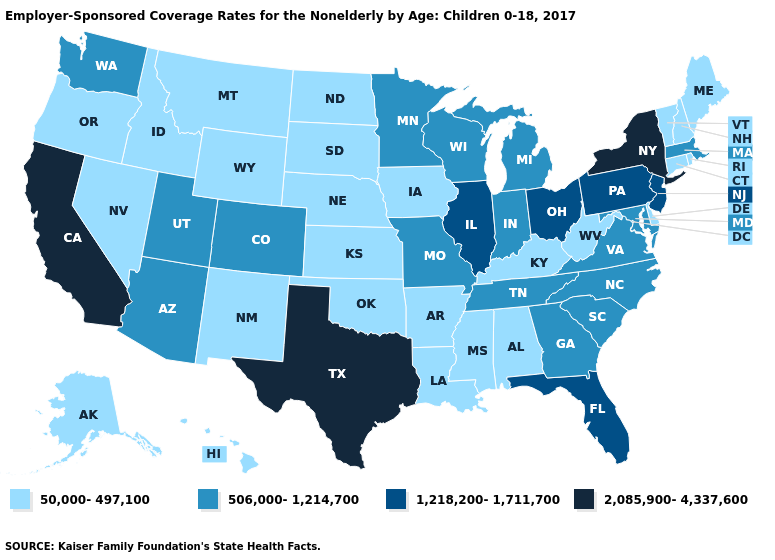What is the value of Nevada?
Give a very brief answer. 50,000-497,100. Name the states that have a value in the range 1,218,200-1,711,700?
Give a very brief answer. Florida, Illinois, New Jersey, Ohio, Pennsylvania. Does Montana have the lowest value in the USA?
Keep it brief. Yes. Does the map have missing data?
Quick response, please. No. Name the states that have a value in the range 1,218,200-1,711,700?
Keep it brief. Florida, Illinois, New Jersey, Ohio, Pennsylvania. Name the states that have a value in the range 2,085,900-4,337,600?
Answer briefly. California, New York, Texas. What is the lowest value in the USA?
Quick response, please. 50,000-497,100. Which states have the lowest value in the MidWest?
Quick response, please. Iowa, Kansas, Nebraska, North Dakota, South Dakota. Does Oklahoma have the lowest value in the South?
Keep it brief. Yes. Does New York have the highest value in the USA?
Quick response, please. Yes. Does the first symbol in the legend represent the smallest category?
Concise answer only. Yes. What is the value of Nebraska?
Write a very short answer. 50,000-497,100. Name the states that have a value in the range 1,218,200-1,711,700?
Quick response, please. Florida, Illinois, New Jersey, Ohio, Pennsylvania. Does Arizona have the lowest value in the West?
Concise answer only. No. Name the states that have a value in the range 2,085,900-4,337,600?
Short answer required. California, New York, Texas. 